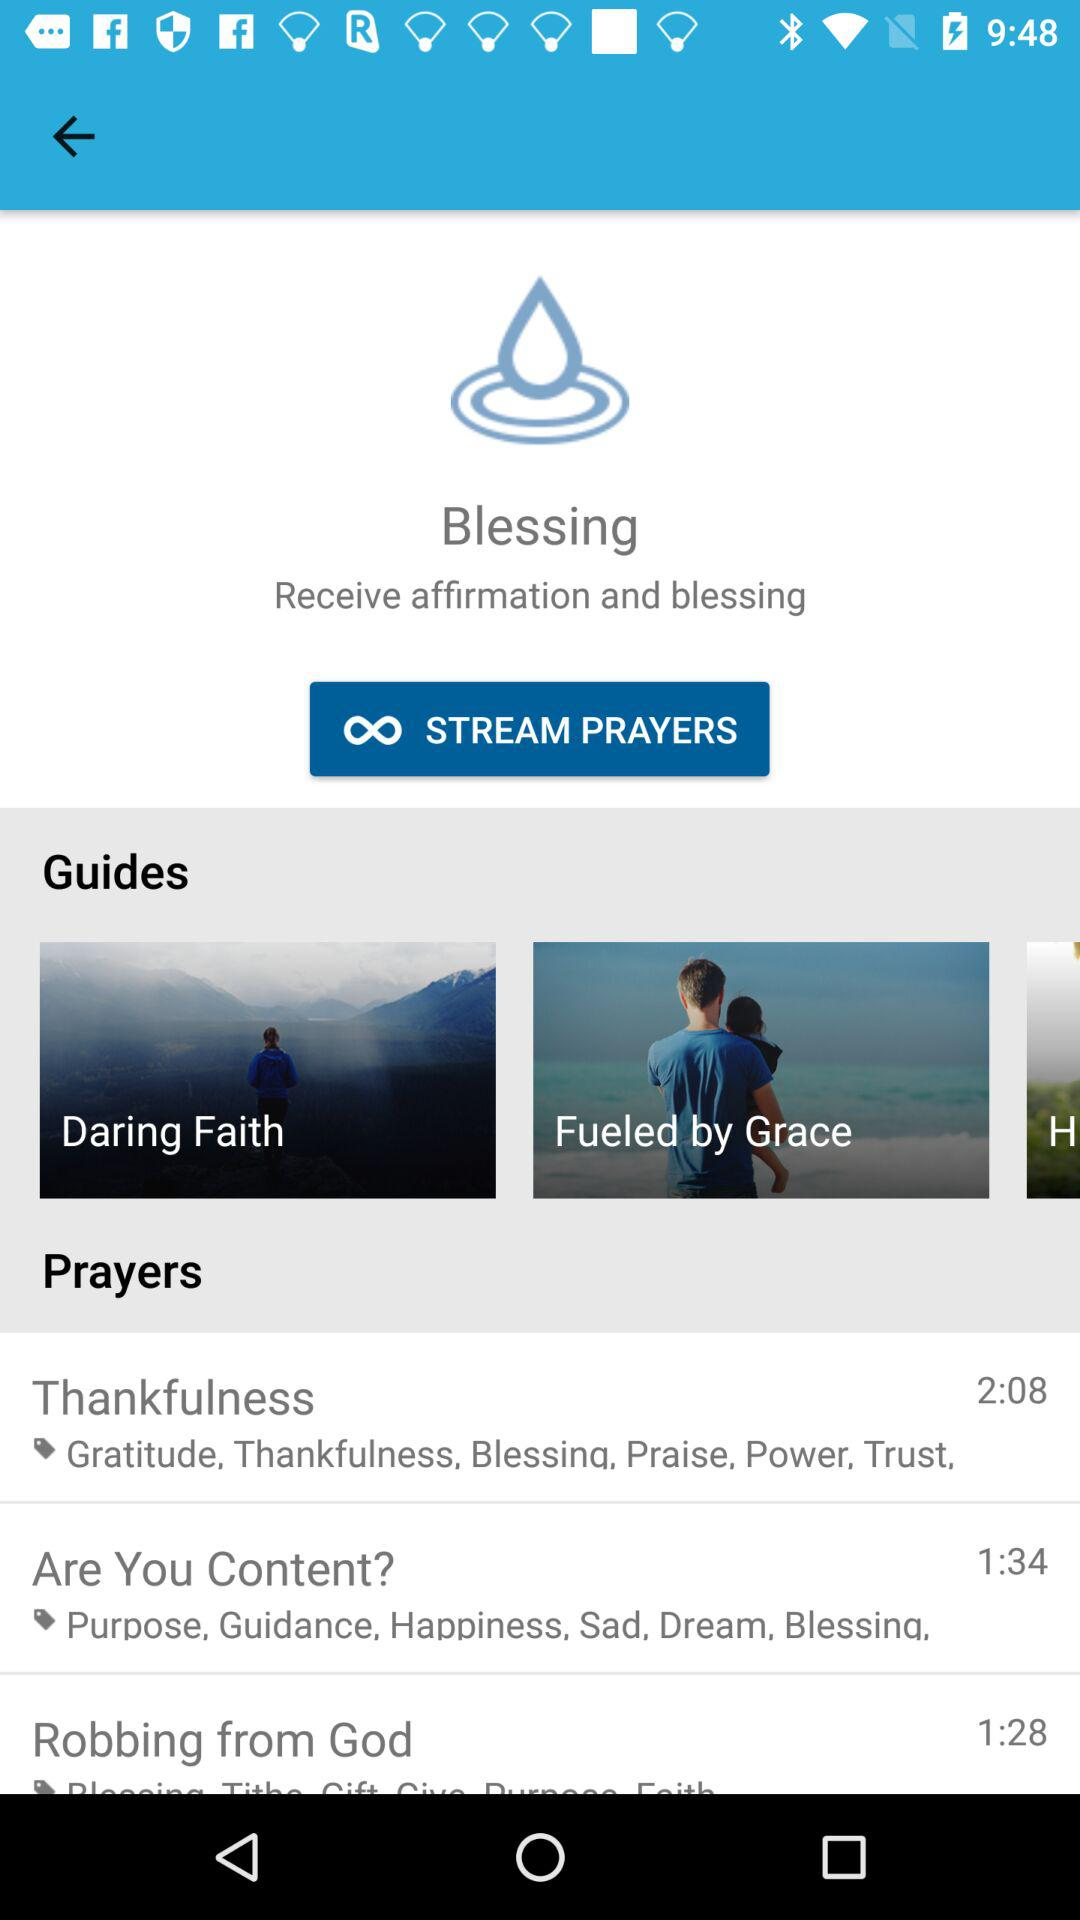How many guides are there?
Answer the question using a single word or phrase. 3 